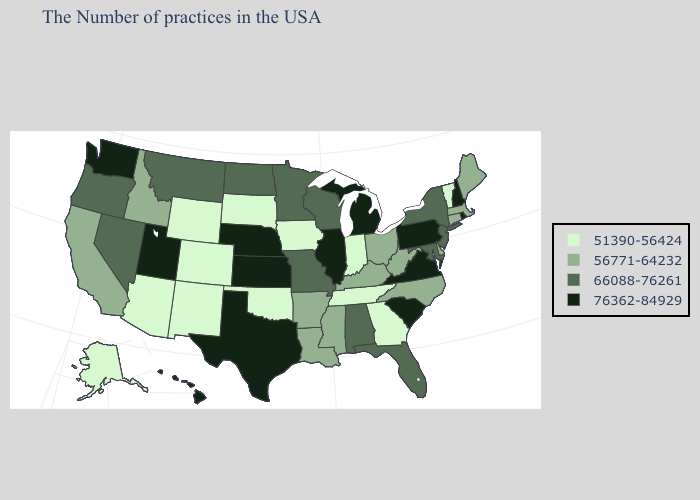What is the value of Nevada?
Short answer required. 66088-76261. What is the value of Florida?
Be succinct. 66088-76261. What is the highest value in states that border Florida?
Be succinct. 66088-76261. Name the states that have a value in the range 76362-84929?
Give a very brief answer. Rhode Island, New Hampshire, Pennsylvania, Virginia, South Carolina, Michigan, Illinois, Kansas, Nebraska, Texas, Utah, Washington, Hawaii. Among the states that border Wisconsin , does Minnesota have the lowest value?
Write a very short answer. No. What is the lowest value in states that border Rhode Island?
Quick response, please. 56771-64232. What is the value of Oklahoma?
Keep it brief. 51390-56424. Name the states that have a value in the range 56771-64232?
Write a very short answer. Maine, Massachusetts, Connecticut, Delaware, North Carolina, West Virginia, Ohio, Kentucky, Mississippi, Louisiana, Arkansas, Idaho, California. What is the highest value in states that border Missouri?
Short answer required. 76362-84929. What is the highest value in the USA?
Keep it brief. 76362-84929. What is the value of California?
Answer briefly. 56771-64232. What is the value of Arizona?
Quick response, please. 51390-56424. Does Arkansas have the same value as Rhode Island?
Short answer required. No. Name the states that have a value in the range 51390-56424?
Concise answer only. Vermont, Georgia, Indiana, Tennessee, Iowa, Oklahoma, South Dakota, Wyoming, Colorado, New Mexico, Arizona, Alaska. 